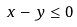<formula> <loc_0><loc_0><loc_500><loc_500>x - y \leq 0</formula> 